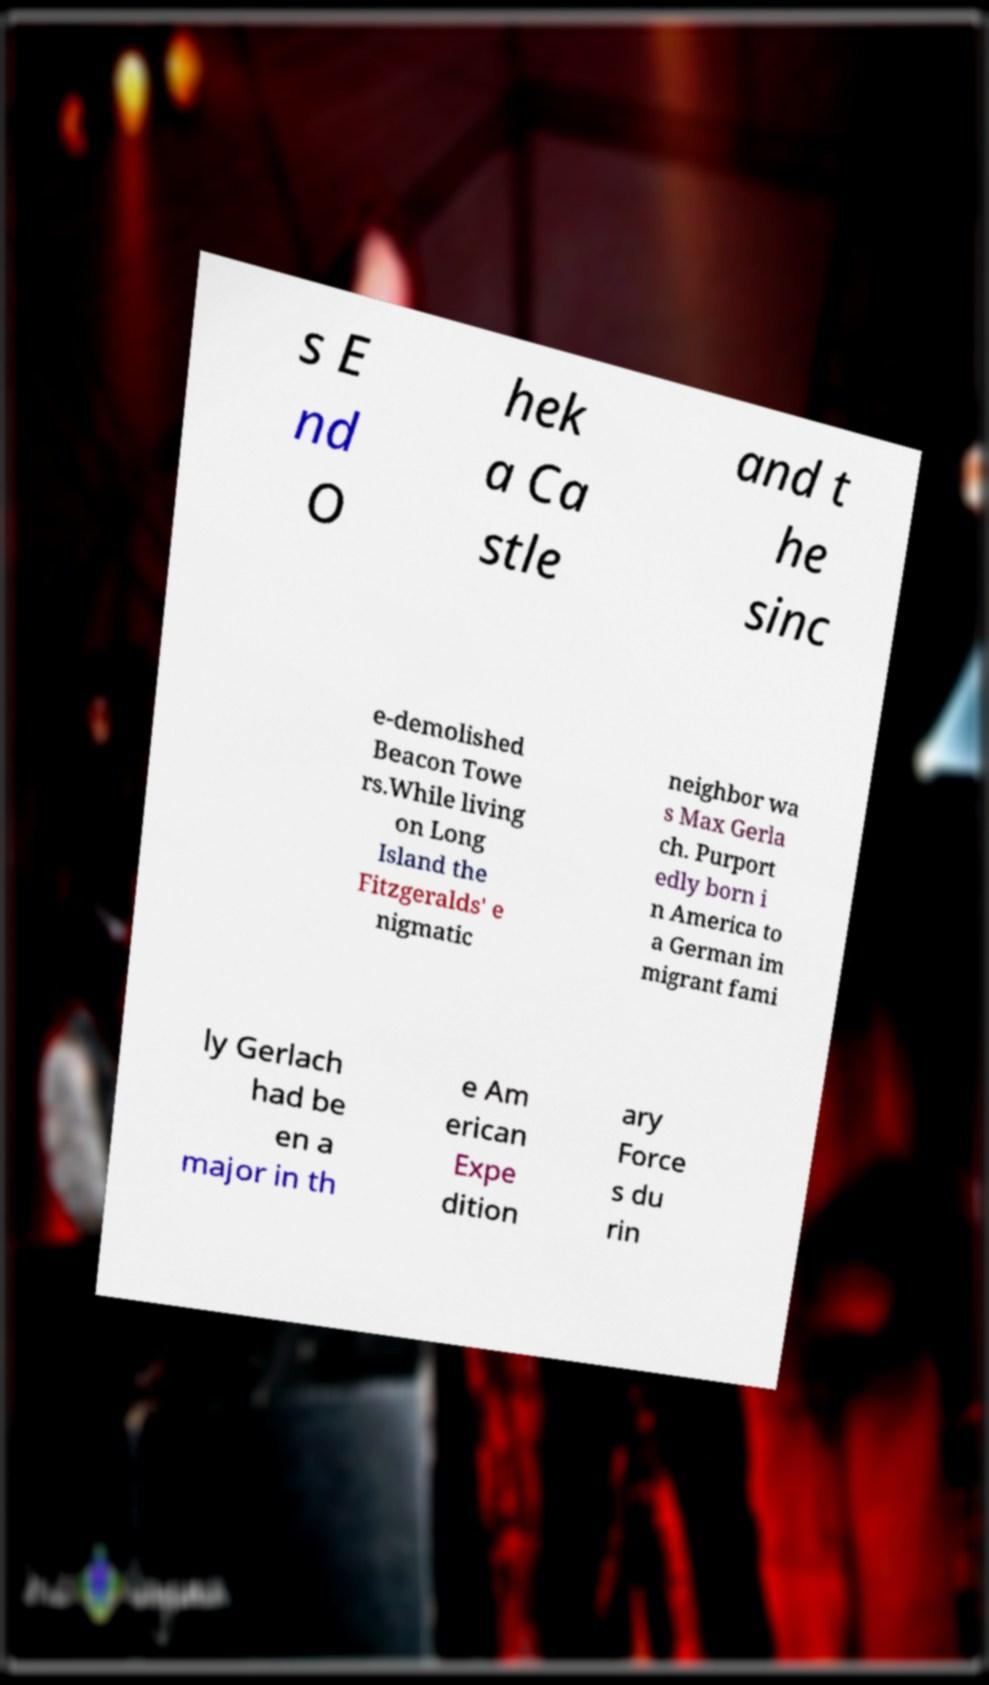Can you read and provide the text displayed in the image?This photo seems to have some interesting text. Can you extract and type it out for me? s E nd O hek a Ca stle and t he sinc e-demolished Beacon Towe rs.While living on Long Island the Fitzgeralds' e nigmatic neighbor wa s Max Gerla ch. Purport edly born i n America to a German im migrant fami ly Gerlach had be en a major in th e Am erican Expe dition ary Force s du rin 